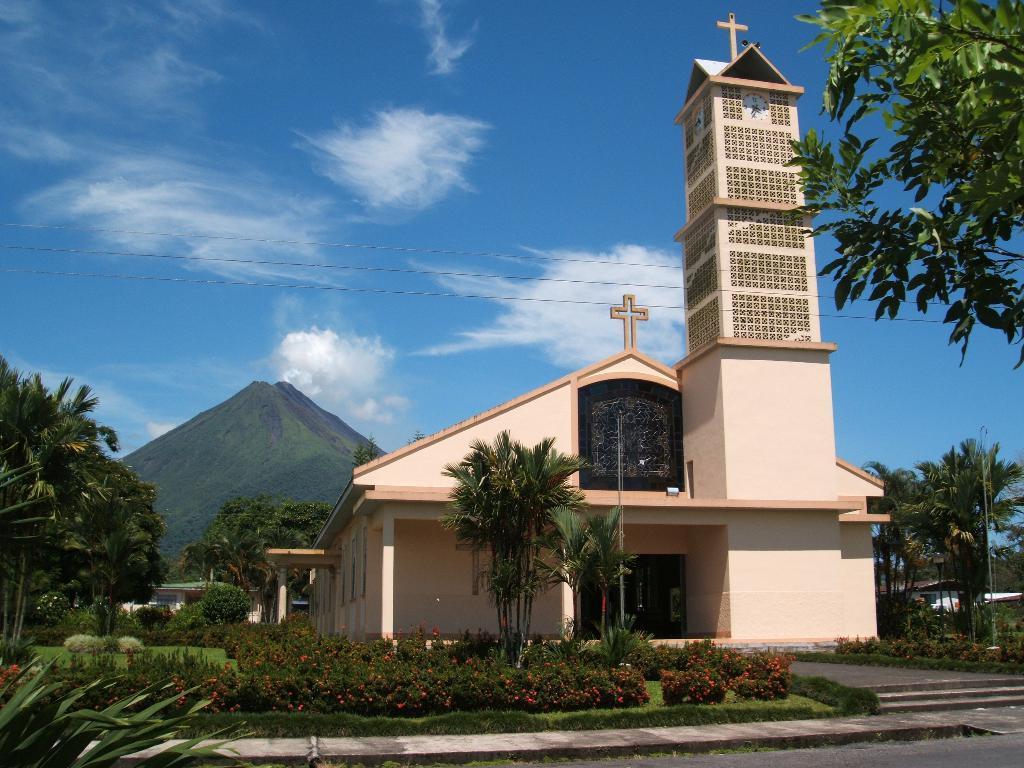Describe this image in one or two sentences. In this picture there is a building in the foreground. At the back there are buildings and trees and there is a mountain. In the foreground there are flowers on the plants. At the top there is sky and there are clouds and wires. At the bottom there is a road. 